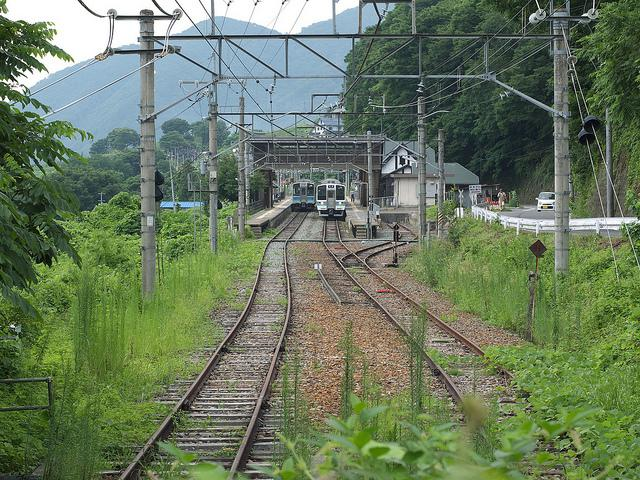How many trains could be traveling underneath of these wires overhanging the train track? two 